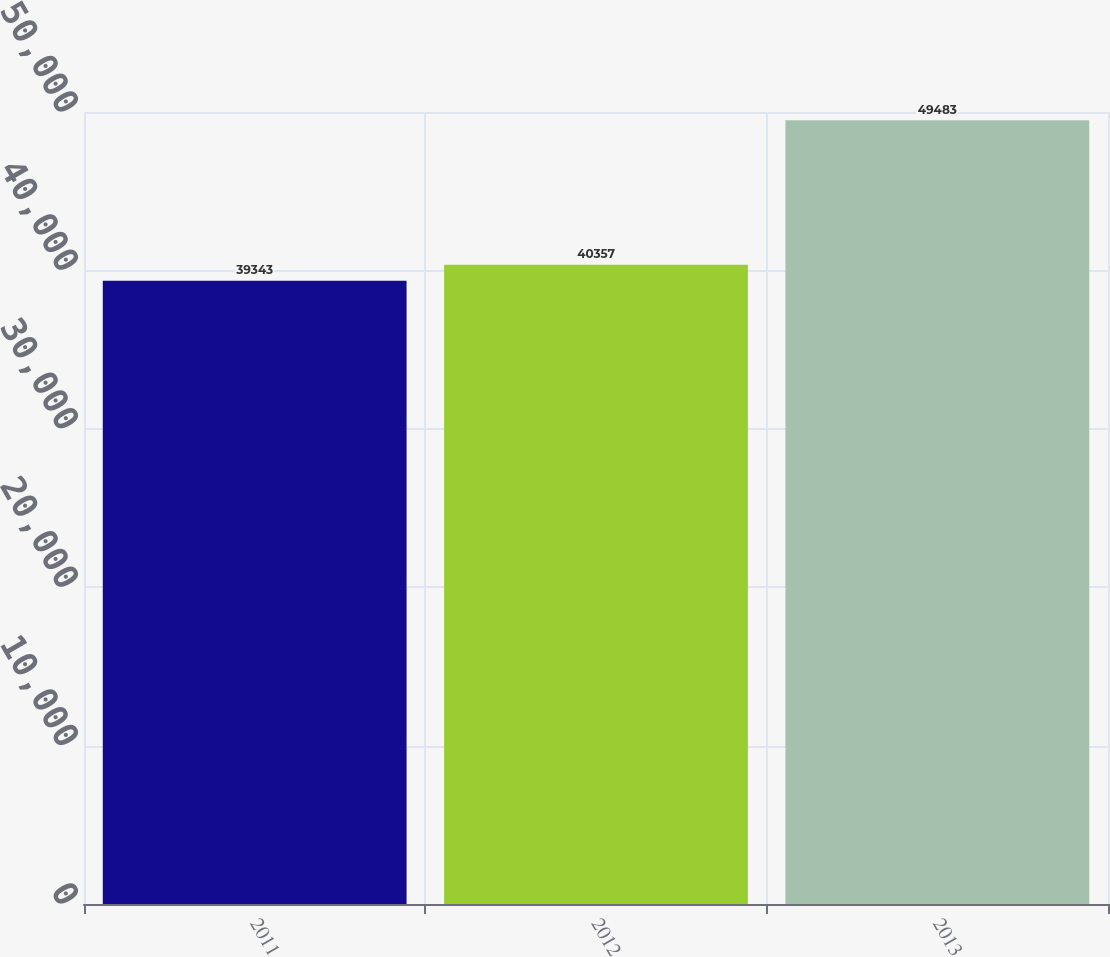<chart> <loc_0><loc_0><loc_500><loc_500><bar_chart><fcel>2011<fcel>2012<fcel>2013<nl><fcel>39343<fcel>40357<fcel>49483<nl></chart> 